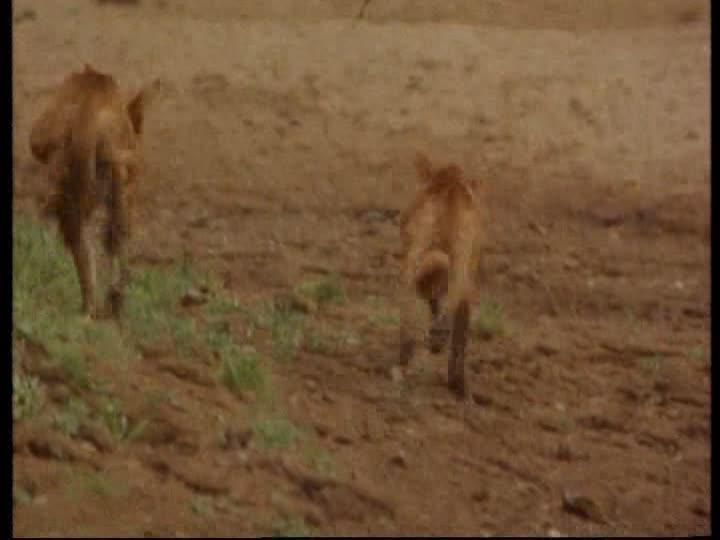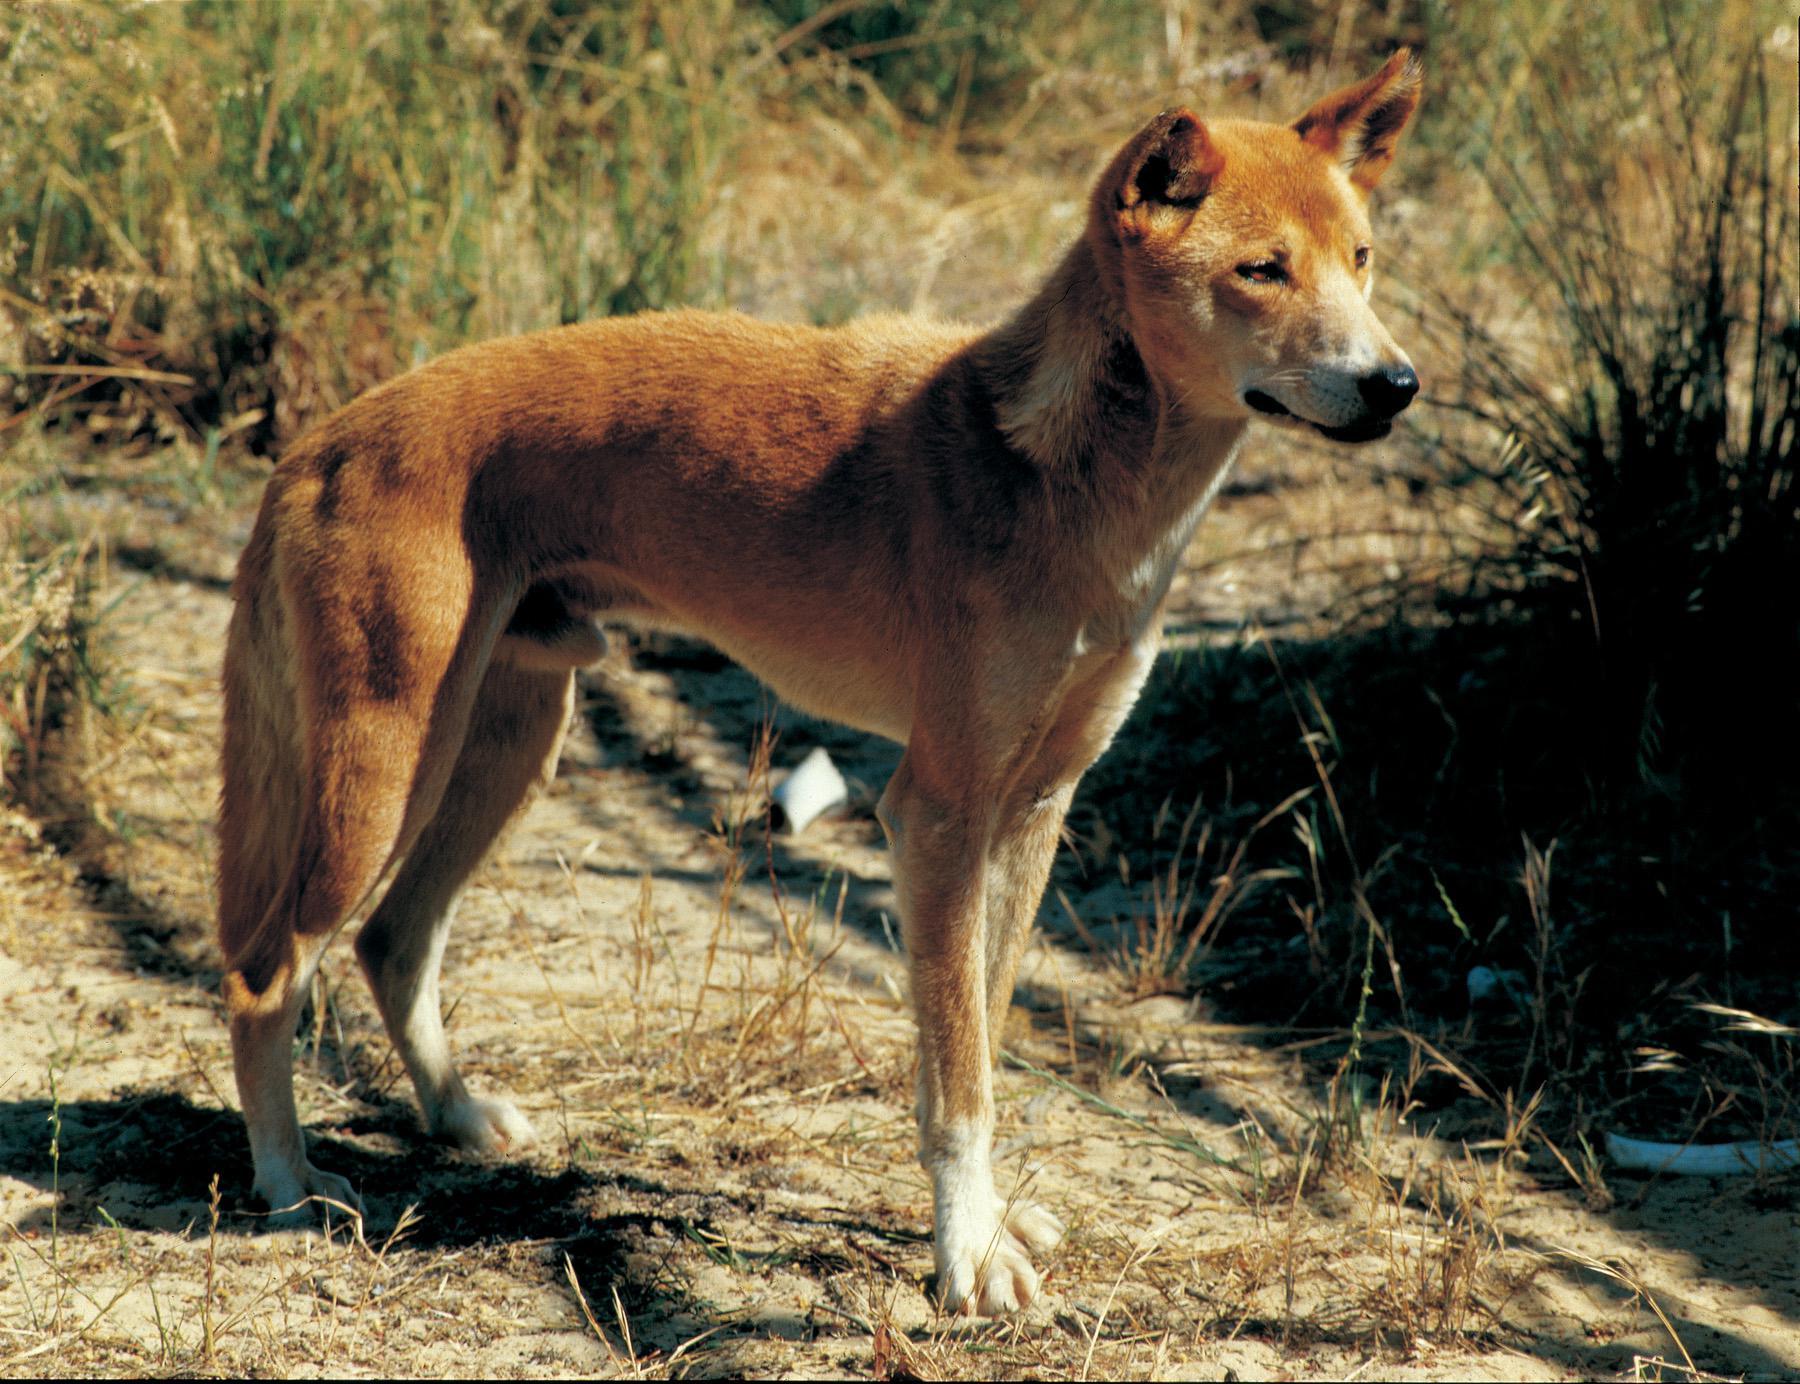The first image is the image on the left, the second image is the image on the right. Given the left and right images, does the statement "Each picture has 1 dog" hold true? Answer yes or no. No. The first image is the image on the left, the second image is the image on the right. Assess this claim about the two images: "The image on the left shows two animals.". Correct or not? Answer yes or no. Yes. 